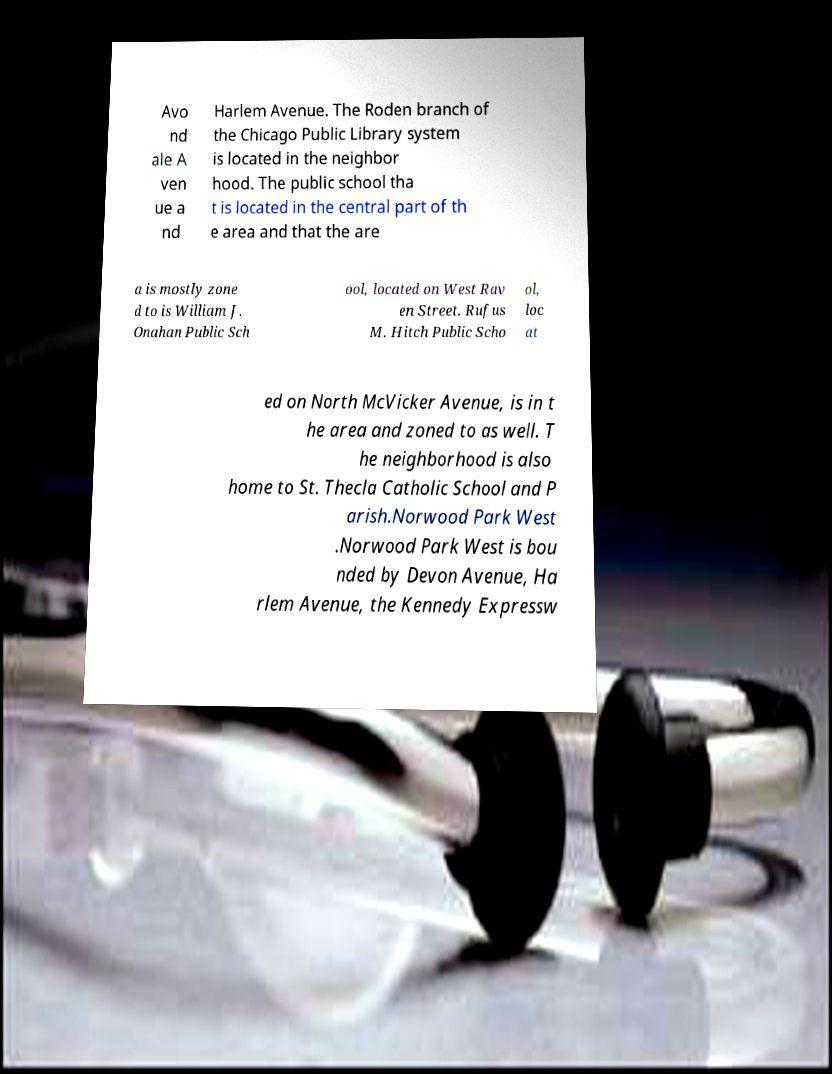Can you accurately transcribe the text from the provided image for me? Avo nd ale A ven ue a nd Harlem Avenue. The Roden branch of the Chicago Public Library system is located in the neighbor hood. The public school tha t is located in the central part of th e area and that the are a is mostly zone d to is William J. Onahan Public Sch ool, located on West Rav en Street. Rufus M. Hitch Public Scho ol, loc at ed on North McVicker Avenue, is in t he area and zoned to as well. T he neighborhood is also home to St. Thecla Catholic School and P arish.Norwood Park West .Norwood Park West is bou nded by Devon Avenue, Ha rlem Avenue, the Kennedy Expressw 